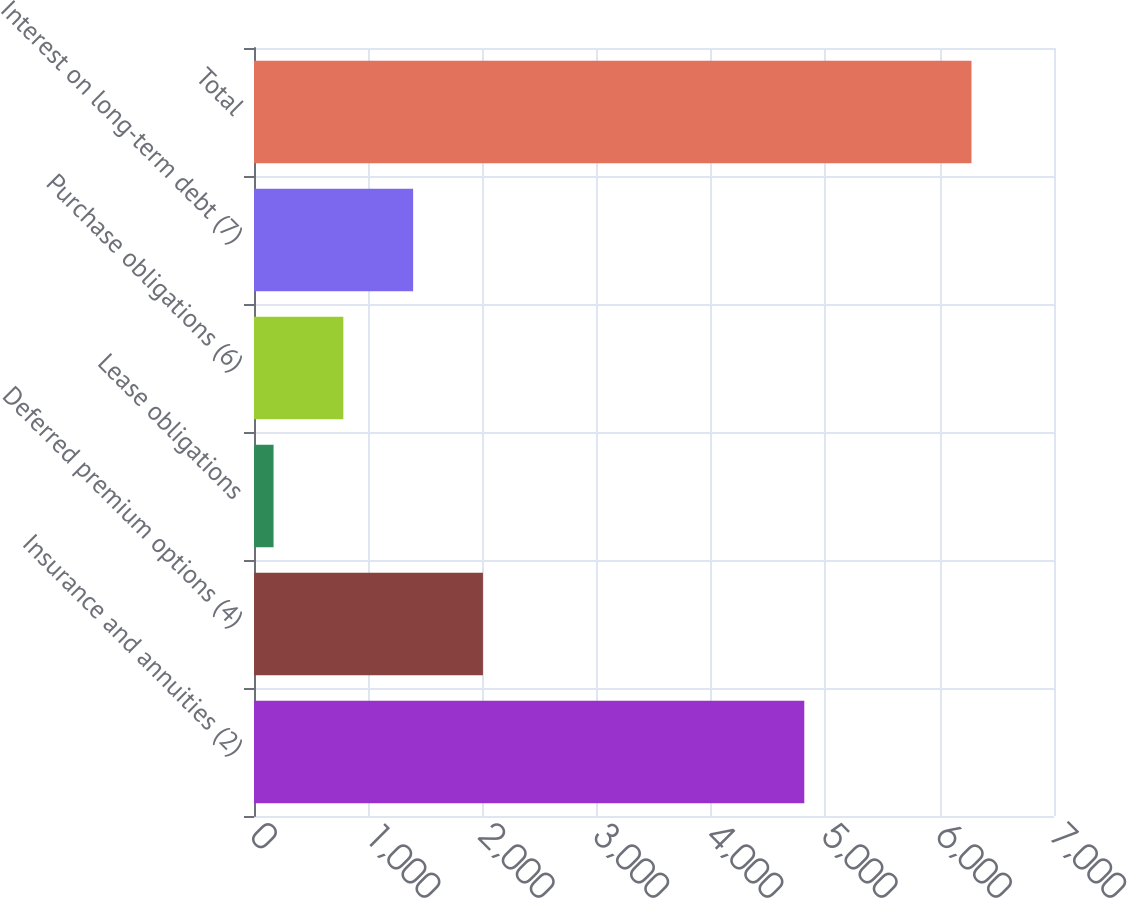Convert chart to OTSL. <chart><loc_0><loc_0><loc_500><loc_500><bar_chart><fcel>Insurance and annuities (2)<fcel>Deferred premium options (4)<fcel>Lease obligations<fcel>Purchase obligations (6)<fcel>Interest on long-term debt (7)<fcel>Total<nl><fcel>4815<fcel>2003.1<fcel>171<fcel>781.7<fcel>1392.4<fcel>6278<nl></chart> 